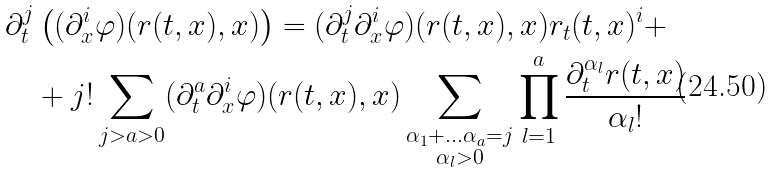Convert formula to latex. <formula><loc_0><loc_0><loc_500><loc_500>\partial _ { t } ^ { j } & \left ( ( \partial _ { x } ^ { i } \varphi ) ( r ( t , x ) , x ) \right ) = ( \partial _ { t } ^ { j } \partial _ { x } ^ { i } \varphi ) ( r ( t , x ) , x ) r _ { t } ( t , x ) ^ { i } + \\ & + j ! \sum _ { j > a > 0 } ( \partial _ { t } ^ { a } \partial _ { x } ^ { i } \varphi ) ( r ( t , x ) , x ) \sum _ { \substack { \alpha _ { 1 } + \dots \alpha _ { a } = j \\ \alpha _ { l } > 0 } } \prod _ { l = 1 } ^ { a } \frac { \partial _ { t } ^ { \alpha _ { l } } r ( t , x ) } { \alpha _ { l } ! }</formula> 